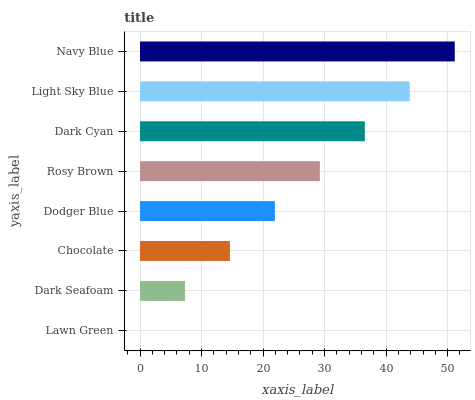Is Lawn Green the minimum?
Answer yes or no. Yes. Is Navy Blue the maximum?
Answer yes or no. Yes. Is Dark Seafoam the minimum?
Answer yes or no. No. Is Dark Seafoam the maximum?
Answer yes or no. No. Is Dark Seafoam greater than Lawn Green?
Answer yes or no. Yes. Is Lawn Green less than Dark Seafoam?
Answer yes or no. Yes. Is Lawn Green greater than Dark Seafoam?
Answer yes or no. No. Is Dark Seafoam less than Lawn Green?
Answer yes or no. No. Is Rosy Brown the high median?
Answer yes or no. Yes. Is Dodger Blue the low median?
Answer yes or no. Yes. Is Chocolate the high median?
Answer yes or no. No. Is Dark Cyan the low median?
Answer yes or no. No. 